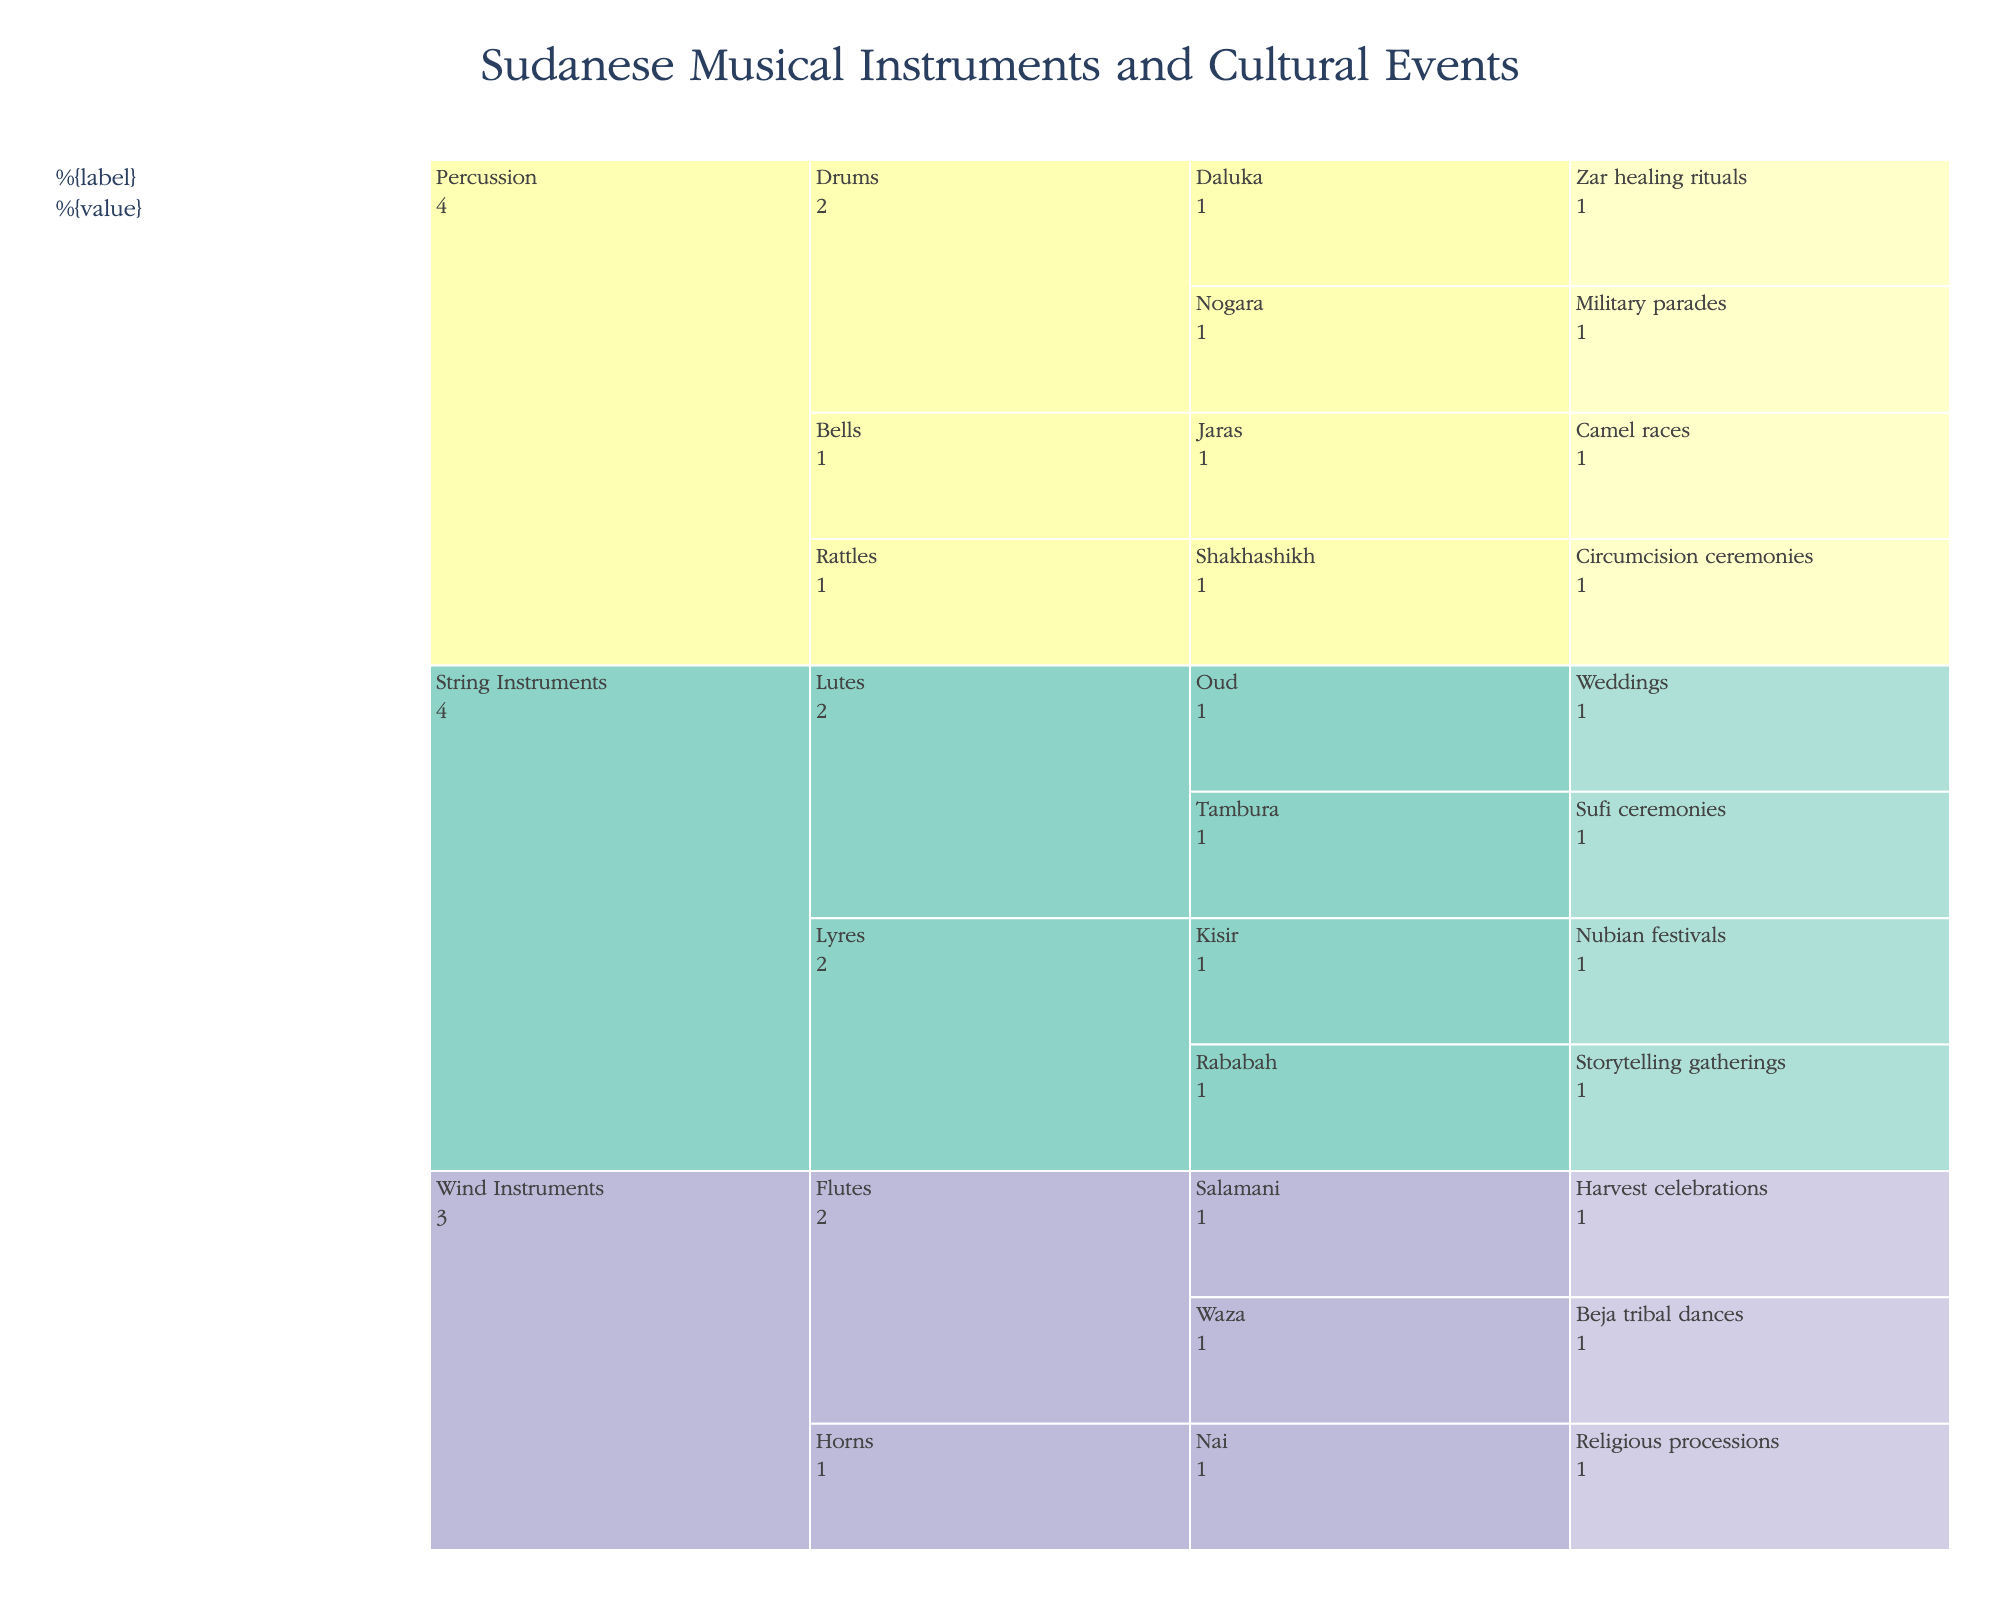What's the title of the chart? The title is displayed at the top of the chart, usually in a larger and bolder font.
Answer: Sudanese Musical Instruments and Cultural Events What type of instrument is used in weddings? To answer this, you look under the "Cultural Event" branch labeled "Weddings" and trace it back to its respective instrument and subcategories.
Answer: Oud Which subcategory of instruments is used for military parades? Identify "Military parades" under the "Cultural Event" branch and trace back to find its instrument and subcategory.
Answer: Drums How many cultural events involve the usage of percussion instruments? Count the number of cultural events that fall under the branch for percussion instruments.
Answer: Four Are more cultural events associated with wind instruments or string instruments? Compare the number of cultural events within the wind instruments and string instruments categories.
Answer: Wind instruments (Three) Which category of instruments is associated with Sufi ceremonies? Locate "Sufi ceremonies" under the "Cultural Event" branch and trace back to its respective category.
Answer: String Instruments How many types of flutes are listed, and for which events are they used? Count the different types of flutes and list the associated events by tracing from the "Flutes" subcategory.
Answer: Two; Salamani (Harvest celebrations), Waza (Beja tribal dances) Which cultural event uses the most distinctive instrument (not shared with any other events)? Identify the event whose instrument isn't shared by any other event in the chart.
Answer: Sufi ceremonies (Tambura) Can you name the instrument used during camel races? Trace from the "Camel races" branch back to its respective instrument and subcategory.
Answer: Jaras How do the number of events involving musical instruments for religious purposes compare to those for harvest celebrations? Compare the number of events labeled under each category.
Answer: Religious processions: one; Harvest celebrations: one 